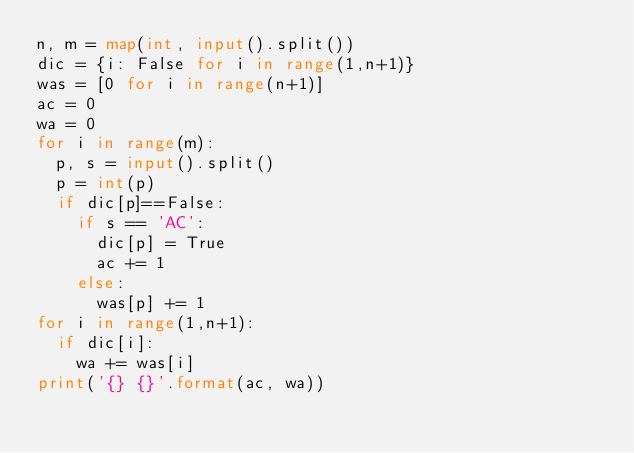Convert code to text. <code><loc_0><loc_0><loc_500><loc_500><_Python_>n, m = map(int, input().split())
dic = {i: False for i in range(1,n+1)}
was = [0 for i in range(n+1)]
ac = 0
wa = 0
for i in range(m):
  p, s = input().split()
  p = int(p)
  if dic[p]==False:
    if s == 'AC':
      dic[p] = True
      ac += 1
    else:
      was[p] += 1
for i in range(1,n+1):
  if dic[i]:
    wa += was[i]
print('{} {}'.format(ac, wa))</code> 